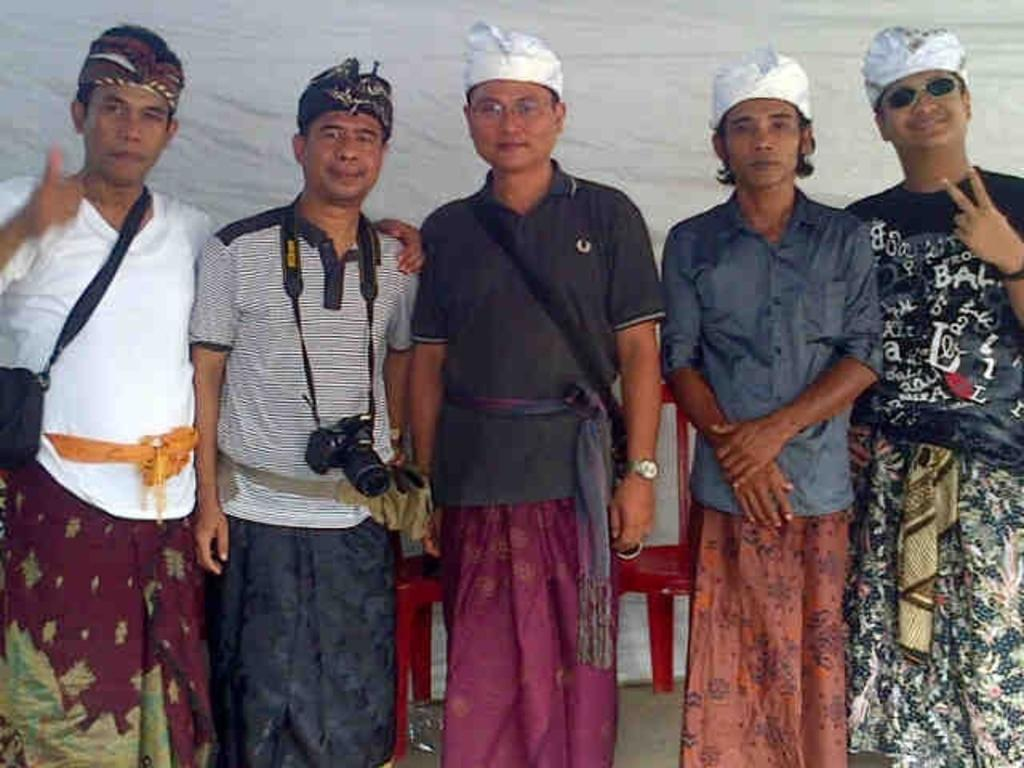Who is present in the image? There are people in the image. What are the people doing in the image? The people are standing and taking a picture. What type of joke is being told by the people in the image? There is no indication in the image that a joke is being told; the people are simply taking a picture. 